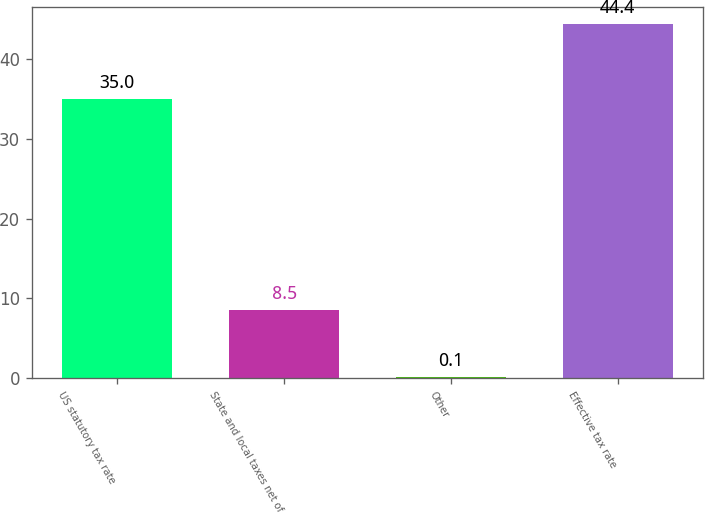<chart> <loc_0><loc_0><loc_500><loc_500><bar_chart><fcel>US statutory tax rate<fcel>State and local taxes net of<fcel>Other<fcel>Effective tax rate<nl><fcel>35<fcel>8.5<fcel>0.1<fcel>44.4<nl></chart> 